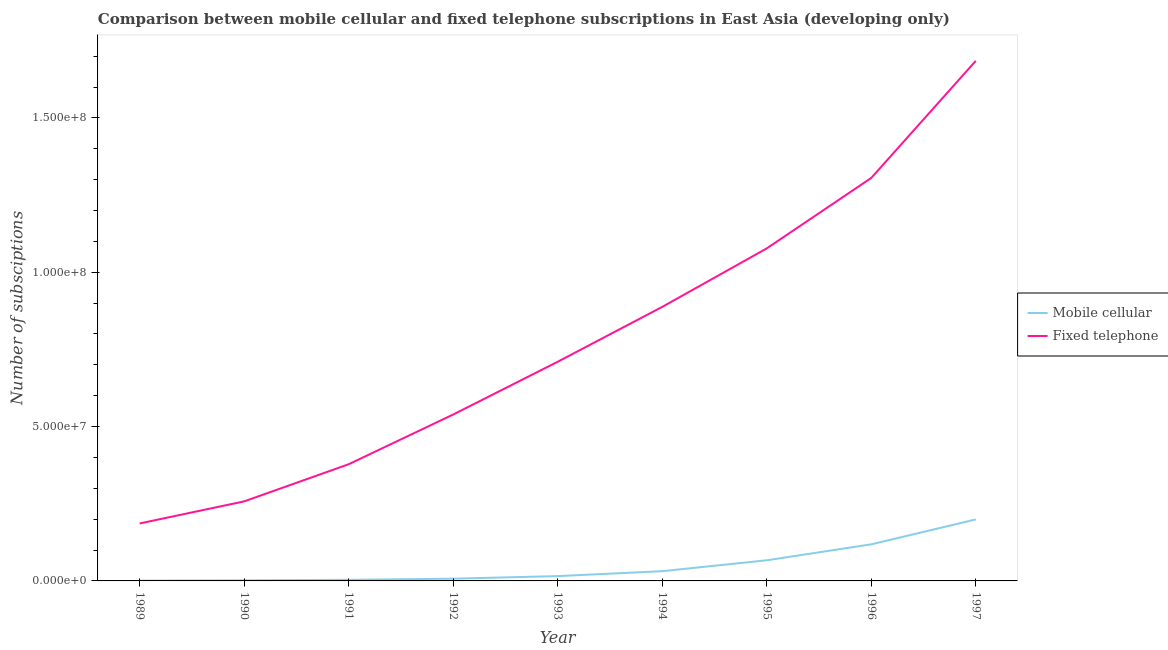How many different coloured lines are there?
Give a very brief answer. 2. Does the line corresponding to number of fixed telephone subscriptions intersect with the line corresponding to number of mobile cellular subscriptions?
Offer a terse response. No. What is the number of fixed telephone subscriptions in 1992?
Provide a succinct answer. 5.39e+07. Across all years, what is the maximum number of mobile cellular subscriptions?
Provide a succinct answer. 1.99e+07. Across all years, what is the minimum number of mobile cellular subscriptions?
Keep it short and to the point. 1.02e+05. In which year was the number of mobile cellular subscriptions maximum?
Provide a short and direct response. 1997. In which year was the number of mobile cellular subscriptions minimum?
Offer a terse response. 1989. What is the total number of fixed telephone subscriptions in the graph?
Provide a short and direct response. 7.03e+08. What is the difference between the number of fixed telephone subscriptions in 1989 and that in 1993?
Provide a succinct answer. -5.24e+07. What is the difference between the number of mobile cellular subscriptions in 1992 and the number of fixed telephone subscriptions in 1997?
Ensure brevity in your answer.  -1.68e+08. What is the average number of mobile cellular subscriptions per year?
Your response must be concise. 4.95e+06. In the year 1990, what is the difference between the number of mobile cellular subscriptions and number of fixed telephone subscriptions?
Keep it short and to the point. -2.56e+07. In how many years, is the number of mobile cellular subscriptions greater than 50000000?
Keep it short and to the point. 0. What is the ratio of the number of fixed telephone subscriptions in 1990 to that in 1994?
Give a very brief answer. 0.29. Is the number of mobile cellular subscriptions in 1992 less than that in 1996?
Make the answer very short. Yes. What is the difference between the highest and the second highest number of mobile cellular subscriptions?
Give a very brief answer. 8.07e+06. What is the difference between the highest and the lowest number of fixed telephone subscriptions?
Provide a succinct answer. 1.50e+08. Is the number of mobile cellular subscriptions strictly greater than the number of fixed telephone subscriptions over the years?
Give a very brief answer. No. Is the number of mobile cellular subscriptions strictly less than the number of fixed telephone subscriptions over the years?
Offer a terse response. Yes. Are the values on the major ticks of Y-axis written in scientific E-notation?
Keep it short and to the point. Yes. Does the graph contain any zero values?
Provide a short and direct response. No. Does the graph contain grids?
Provide a succinct answer. No. Where does the legend appear in the graph?
Offer a terse response. Center right. How are the legend labels stacked?
Offer a very short reply. Vertical. What is the title of the graph?
Offer a terse response. Comparison between mobile cellular and fixed telephone subscriptions in East Asia (developing only). Does "Measles" appear as one of the legend labels in the graph?
Make the answer very short. No. What is the label or title of the Y-axis?
Provide a succinct answer. Number of subsciptions. What is the Number of subsciptions of Mobile cellular in 1989?
Make the answer very short. 1.02e+05. What is the Number of subsciptions in Fixed telephone in 1989?
Offer a very short reply. 1.86e+07. What is the Number of subsciptions in Mobile cellular in 1990?
Offer a terse response. 1.86e+05. What is the Number of subsciptions in Fixed telephone in 1990?
Make the answer very short. 2.58e+07. What is the Number of subsciptions in Mobile cellular in 1991?
Make the answer very short. 3.60e+05. What is the Number of subsciptions in Fixed telephone in 1991?
Offer a very short reply. 3.78e+07. What is the Number of subsciptions of Mobile cellular in 1992?
Make the answer very short. 7.21e+05. What is the Number of subsciptions of Fixed telephone in 1992?
Provide a succinct answer. 5.39e+07. What is the Number of subsciptions of Mobile cellular in 1993?
Offer a very short reply. 1.56e+06. What is the Number of subsciptions in Fixed telephone in 1993?
Your answer should be compact. 7.10e+07. What is the Number of subsciptions in Mobile cellular in 1994?
Provide a succinct answer. 3.16e+06. What is the Number of subsciptions in Fixed telephone in 1994?
Make the answer very short. 8.88e+07. What is the Number of subsciptions of Mobile cellular in 1995?
Provide a short and direct response. 6.68e+06. What is the Number of subsciptions in Fixed telephone in 1995?
Your answer should be compact. 1.08e+08. What is the Number of subsciptions in Mobile cellular in 1996?
Provide a short and direct response. 1.19e+07. What is the Number of subsciptions in Fixed telephone in 1996?
Your answer should be compact. 1.31e+08. What is the Number of subsciptions of Mobile cellular in 1997?
Make the answer very short. 1.99e+07. What is the Number of subsciptions of Fixed telephone in 1997?
Your response must be concise. 1.68e+08. Across all years, what is the maximum Number of subsciptions of Mobile cellular?
Offer a terse response. 1.99e+07. Across all years, what is the maximum Number of subsciptions of Fixed telephone?
Ensure brevity in your answer.  1.68e+08. Across all years, what is the minimum Number of subsciptions of Mobile cellular?
Offer a very short reply. 1.02e+05. Across all years, what is the minimum Number of subsciptions in Fixed telephone?
Offer a terse response. 1.86e+07. What is the total Number of subsciptions in Mobile cellular in the graph?
Your answer should be compact. 4.45e+07. What is the total Number of subsciptions of Fixed telephone in the graph?
Ensure brevity in your answer.  7.03e+08. What is the difference between the Number of subsciptions in Mobile cellular in 1989 and that in 1990?
Offer a terse response. -8.42e+04. What is the difference between the Number of subsciptions in Fixed telephone in 1989 and that in 1990?
Offer a very short reply. -7.16e+06. What is the difference between the Number of subsciptions of Mobile cellular in 1989 and that in 1991?
Your answer should be very brief. -2.58e+05. What is the difference between the Number of subsciptions in Fixed telephone in 1989 and that in 1991?
Your response must be concise. -1.92e+07. What is the difference between the Number of subsciptions of Mobile cellular in 1989 and that in 1992?
Provide a short and direct response. -6.19e+05. What is the difference between the Number of subsciptions of Fixed telephone in 1989 and that in 1992?
Ensure brevity in your answer.  -3.53e+07. What is the difference between the Number of subsciptions in Mobile cellular in 1989 and that in 1993?
Your answer should be compact. -1.46e+06. What is the difference between the Number of subsciptions of Fixed telephone in 1989 and that in 1993?
Offer a very short reply. -5.24e+07. What is the difference between the Number of subsciptions of Mobile cellular in 1989 and that in 1994?
Offer a very short reply. -3.05e+06. What is the difference between the Number of subsciptions of Fixed telephone in 1989 and that in 1994?
Keep it short and to the point. -7.02e+07. What is the difference between the Number of subsciptions in Mobile cellular in 1989 and that in 1995?
Provide a succinct answer. -6.58e+06. What is the difference between the Number of subsciptions in Fixed telephone in 1989 and that in 1995?
Ensure brevity in your answer.  -8.91e+07. What is the difference between the Number of subsciptions in Mobile cellular in 1989 and that in 1996?
Ensure brevity in your answer.  -1.17e+07. What is the difference between the Number of subsciptions in Fixed telephone in 1989 and that in 1996?
Your response must be concise. -1.12e+08. What is the difference between the Number of subsciptions in Mobile cellular in 1989 and that in 1997?
Your answer should be compact. -1.98e+07. What is the difference between the Number of subsciptions of Fixed telephone in 1989 and that in 1997?
Ensure brevity in your answer.  -1.50e+08. What is the difference between the Number of subsciptions in Mobile cellular in 1990 and that in 1991?
Provide a succinct answer. -1.74e+05. What is the difference between the Number of subsciptions in Fixed telephone in 1990 and that in 1991?
Make the answer very short. -1.20e+07. What is the difference between the Number of subsciptions of Mobile cellular in 1990 and that in 1992?
Provide a succinct answer. -5.35e+05. What is the difference between the Number of subsciptions in Fixed telephone in 1990 and that in 1992?
Offer a very short reply. -2.81e+07. What is the difference between the Number of subsciptions in Mobile cellular in 1990 and that in 1993?
Make the answer very short. -1.37e+06. What is the difference between the Number of subsciptions of Fixed telephone in 1990 and that in 1993?
Ensure brevity in your answer.  -4.52e+07. What is the difference between the Number of subsciptions of Mobile cellular in 1990 and that in 1994?
Provide a short and direct response. -2.97e+06. What is the difference between the Number of subsciptions of Fixed telephone in 1990 and that in 1994?
Offer a terse response. -6.30e+07. What is the difference between the Number of subsciptions in Mobile cellular in 1990 and that in 1995?
Provide a short and direct response. -6.50e+06. What is the difference between the Number of subsciptions in Fixed telephone in 1990 and that in 1995?
Ensure brevity in your answer.  -8.20e+07. What is the difference between the Number of subsciptions in Mobile cellular in 1990 and that in 1996?
Your answer should be very brief. -1.17e+07. What is the difference between the Number of subsciptions in Fixed telephone in 1990 and that in 1996?
Ensure brevity in your answer.  -1.05e+08. What is the difference between the Number of subsciptions in Mobile cellular in 1990 and that in 1997?
Give a very brief answer. -1.97e+07. What is the difference between the Number of subsciptions of Fixed telephone in 1990 and that in 1997?
Your answer should be compact. -1.43e+08. What is the difference between the Number of subsciptions of Mobile cellular in 1991 and that in 1992?
Your answer should be very brief. -3.61e+05. What is the difference between the Number of subsciptions of Fixed telephone in 1991 and that in 1992?
Your response must be concise. -1.61e+07. What is the difference between the Number of subsciptions in Mobile cellular in 1991 and that in 1993?
Make the answer very short. -1.20e+06. What is the difference between the Number of subsciptions of Fixed telephone in 1991 and that in 1993?
Ensure brevity in your answer.  -3.32e+07. What is the difference between the Number of subsciptions of Mobile cellular in 1991 and that in 1994?
Provide a short and direct response. -2.79e+06. What is the difference between the Number of subsciptions of Fixed telephone in 1991 and that in 1994?
Provide a succinct answer. -5.10e+07. What is the difference between the Number of subsciptions of Mobile cellular in 1991 and that in 1995?
Provide a short and direct response. -6.32e+06. What is the difference between the Number of subsciptions in Fixed telephone in 1991 and that in 1995?
Your answer should be very brief. -6.99e+07. What is the difference between the Number of subsciptions of Mobile cellular in 1991 and that in 1996?
Offer a very short reply. -1.15e+07. What is the difference between the Number of subsciptions in Fixed telephone in 1991 and that in 1996?
Your response must be concise. -9.28e+07. What is the difference between the Number of subsciptions of Mobile cellular in 1991 and that in 1997?
Offer a very short reply. -1.96e+07. What is the difference between the Number of subsciptions in Fixed telephone in 1991 and that in 1997?
Your answer should be compact. -1.31e+08. What is the difference between the Number of subsciptions of Mobile cellular in 1992 and that in 1993?
Your response must be concise. -8.37e+05. What is the difference between the Number of subsciptions in Fixed telephone in 1992 and that in 1993?
Your answer should be very brief. -1.71e+07. What is the difference between the Number of subsciptions of Mobile cellular in 1992 and that in 1994?
Provide a succinct answer. -2.43e+06. What is the difference between the Number of subsciptions in Fixed telephone in 1992 and that in 1994?
Make the answer very short. -3.49e+07. What is the difference between the Number of subsciptions of Mobile cellular in 1992 and that in 1995?
Make the answer very short. -5.96e+06. What is the difference between the Number of subsciptions in Fixed telephone in 1992 and that in 1995?
Your answer should be compact. -5.38e+07. What is the difference between the Number of subsciptions in Mobile cellular in 1992 and that in 1996?
Give a very brief answer. -1.11e+07. What is the difference between the Number of subsciptions in Fixed telephone in 1992 and that in 1996?
Offer a very short reply. -7.66e+07. What is the difference between the Number of subsciptions in Mobile cellular in 1992 and that in 1997?
Make the answer very short. -1.92e+07. What is the difference between the Number of subsciptions of Fixed telephone in 1992 and that in 1997?
Provide a succinct answer. -1.15e+08. What is the difference between the Number of subsciptions of Mobile cellular in 1993 and that in 1994?
Offer a terse response. -1.60e+06. What is the difference between the Number of subsciptions in Fixed telephone in 1993 and that in 1994?
Your answer should be compact. -1.78e+07. What is the difference between the Number of subsciptions in Mobile cellular in 1993 and that in 1995?
Provide a succinct answer. -5.12e+06. What is the difference between the Number of subsciptions of Fixed telephone in 1993 and that in 1995?
Provide a short and direct response. -3.67e+07. What is the difference between the Number of subsciptions of Mobile cellular in 1993 and that in 1996?
Your answer should be compact. -1.03e+07. What is the difference between the Number of subsciptions of Fixed telephone in 1993 and that in 1996?
Offer a very short reply. -5.96e+07. What is the difference between the Number of subsciptions of Mobile cellular in 1993 and that in 1997?
Your answer should be compact. -1.84e+07. What is the difference between the Number of subsciptions of Fixed telephone in 1993 and that in 1997?
Provide a short and direct response. -9.75e+07. What is the difference between the Number of subsciptions of Mobile cellular in 1994 and that in 1995?
Provide a succinct answer. -3.53e+06. What is the difference between the Number of subsciptions of Fixed telephone in 1994 and that in 1995?
Your answer should be very brief. -1.89e+07. What is the difference between the Number of subsciptions in Mobile cellular in 1994 and that in 1996?
Your answer should be very brief. -8.70e+06. What is the difference between the Number of subsciptions of Fixed telephone in 1994 and that in 1996?
Give a very brief answer. -4.18e+07. What is the difference between the Number of subsciptions of Mobile cellular in 1994 and that in 1997?
Give a very brief answer. -1.68e+07. What is the difference between the Number of subsciptions of Fixed telephone in 1994 and that in 1997?
Provide a short and direct response. -7.97e+07. What is the difference between the Number of subsciptions of Mobile cellular in 1995 and that in 1996?
Offer a very short reply. -5.17e+06. What is the difference between the Number of subsciptions of Fixed telephone in 1995 and that in 1996?
Give a very brief answer. -2.28e+07. What is the difference between the Number of subsciptions in Mobile cellular in 1995 and that in 1997?
Keep it short and to the point. -1.32e+07. What is the difference between the Number of subsciptions of Fixed telephone in 1995 and that in 1997?
Ensure brevity in your answer.  -6.08e+07. What is the difference between the Number of subsciptions in Mobile cellular in 1996 and that in 1997?
Provide a succinct answer. -8.07e+06. What is the difference between the Number of subsciptions in Fixed telephone in 1996 and that in 1997?
Make the answer very short. -3.79e+07. What is the difference between the Number of subsciptions of Mobile cellular in 1989 and the Number of subsciptions of Fixed telephone in 1990?
Your answer should be compact. -2.57e+07. What is the difference between the Number of subsciptions of Mobile cellular in 1989 and the Number of subsciptions of Fixed telephone in 1991?
Offer a very short reply. -3.77e+07. What is the difference between the Number of subsciptions in Mobile cellular in 1989 and the Number of subsciptions in Fixed telephone in 1992?
Provide a short and direct response. -5.38e+07. What is the difference between the Number of subsciptions in Mobile cellular in 1989 and the Number of subsciptions in Fixed telephone in 1993?
Offer a terse response. -7.09e+07. What is the difference between the Number of subsciptions in Mobile cellular in 1989 and the Number of subsciptions in Fixed telephone in 1994?
Your response must be concise. -8.87e+07. What is the difference between the Number of subsciptions of Mobile cellular in 1989 and the Number of subsciptions of Fixed telephone in 1995?
Give a very brief answer. -1.08e+08. What is the difference between the Number of subsciptions of Mobile cellular in 1989 and the Number of subsciptions of Fixed telephone in 1996?
Keep it short and to the point. -1.30e+08. What is the difference between the Number of subsciptions in Mobile cellular in 1989 and the Number of subsciptions in Fixed telephone in 1997?
Ensure brevity in your answer.  -1.68e+08. What is the difference between the Number of subsciptions in Mobile cellular in 1990 and the Number of subsciptions in Fixed telephone in 1991?
Your answer should be compact. -3.76e+07. What is the difference between the Number of subsciptions of Mobile cellular in 1990 and the Number of subsciptions of Fixed telephone in 1992?
Offer a very short reply. -5.37e+07. What is the difference between the Number of subsciptions of Mobile cellular in 1990 and the Number of subsciptions of Fixed telephone in 1993?
Keep it short and to the point. -7.08e+07. What is the difference between the Number of subsciptions in Mobile cellular in 1990 and the Number of subsciptions in Fixed telephone in 1994?
Offer a terse response. -8.86e+07. What is the difference between the Number of subsciptions in Mobile cellular in 1990 and the Number of subsciptions in Fixed telephone in 1995?
Offer a very short reply. -1.08e+08. What is the difference between the Number of subsciptions of Mobile cellular in 1990 and the Number of subsciptions of Fixed telephone in 1996?
Ensure brevity in your answer.  -1.30e+08. What is the difference between the Number of subsciptions of Mobile cellular in 1990 and the Number of subsciptions of Fixed telephone in 1997?
Ensure brevity in your answer.  -1.68e+08. What is the difference between the Number of subsciptions in Mobile cellular in 1991 and the Number of subsciptions in Fixed telephone in 1992?
Keep it short and to the point. -5.36e+07. What is the difference between the Number of subsciptions of Mobile cellular in 1991 and the Number of subsciptions of Fixed telephone in 1993?
Offer a terse response. -7.06e+07. What is the difference between the Number of subsciptions in Mobile cellular in 1991 and the Number of subsciptions in Fixed telephone in 1994?
Make the answer very short. -8.84e+07. What is the difference between the Number of subsciptions in Mobile cellular in 1991 and the Number of subsciptions in Fixed telephone in 1995?
Keep it short and to the point. -1.07e+08. What is the difference between the Number of subsciptions of Mobile cellular in 1991 and the Number of subsciptions of Fixed telephone in 1996?
Ensure brevity in your answer.  -1.30e+08. What is the difference between the Number of subsciptions in Mobile cellular in 1991 and the Number of subsciptions in Fixed telephone in 1997?
Offer a terse response. -1.68e+08. What is the difference between the Number of subsciptions in Mobile cellular in 1992 and the Number of subsciptions in Fixed telephone in 1993?
Your answer should be compact. -7.03e+07. What is the difference between the Number of subsciptions of Mobile cellular in 1992 and the Number of subsciptions of Fixed telephone in 1994?
Ensure brevity in your answer.  -8.81e+07. What is the difference between the Number of subsciptions in Mobile cellular in 1992 and the Number of subsciptions in Fixed telephone in 1995?
Offer a terse response. -1.07e+08. What is the difference between the Number of subsciptions of Mobile cellular in 1992 and the Number of subsciptions of Fixed telephone in 1996?
Provide a succinct answer. -1.30e+08. What is the difference between the Number of subsciptions in Mobile cellular in 1992 and the Number of subsciptions in Fixed telephone in 1997?
Your answer should be very brief. -1.68e+08. What is the difference between the Number of subsciptions in Mobile cellular in 1993 and the Number of subsciptions in Fixed telephone in 1994?
Make the answer very short. -8.72e+07. What is the difference between the Number of subsciptions in Mobile cellular in 1993 and the Number of subsciptions in Fixed telephone in 1995?
Offer a very short reply. -1.06e+08. What is the difference between the Number of subsciptions of Mobile cellular in 1993 and the Number of subsciptions of Fixed telephone in 1996?
Give a very brief answer. -1.29e+08. What is the difference between the Number of subsciptions of Mobile cellular in 1993 and the Number of subsciptions of Fixed telephone in 1997?
Your answer should be compact. -1.67e+08. What is the difference between the Number of subsciptions in Mobile cellular in 1994 and the Number of subsciptions in Fixed telephone in 1995?
Ensure brevity in your answer.  -1.05e+08. What is the difference between the Number of subsciptions of Mobile cellular in 1994 and the Number of subsciptions of Fixed telephone in 1996?
Give a very brief answer. -1.27e+08. What is the difference between the Number of subsciptions of Mobile cellular in 1994 and the Number of subsciptions of Fixed telephone in 1997?
Ensure brevity in your answer.  -1.65e+08. What is the difference between the Number of subsciptions of Mobile cellular in 1995 and the Number of subsciptions of Fixed telephone in 1996?
Make the answer very short. -1.24e+08. What is the difference between the Number of subsciptions in Mobile cellular in 1995 and the Number of subsciptions in Fixed telephone in 1997?
Your answer should be very brief. -1.62e+08. What is the difference between the Number of subsciptions in Mobile cellular in 1996 and the Number of subsciptions in Fixed telephone in 1997?
Offer a very short reply. -1.57e+08. What is the average Number of subsciptions of Mobile cellular per year?
Keep it short and to the point. 4.95e+06. What is the average Number of subsciptions of Fixed telephone per year?
Provide a short and direct response. 7.81e+07. In the year 1989, what is the difference between the Number of subsciptions of Mobile cellular and Number of subsciptions of Fixed telephone?
Your response must be concise. -1.85e+07. In the year 1990, what is the difference between the Number of subsciptions in Mobile cellular and Number of subsciptions in Fixed telephone?
Ensure brevity in your answer.  -2.56e+07. In the year 1991, what is the difference between the Number of subsciptions in Mobile cellular and Number of subsciptions in Fixed telephone?
Offer a terse response. -3.74e+07. In the year 1992, what is the difference between the Number of subsciptions in Mobile cellular and Number of subsciptions in Fixed telephone?
Provide a short and direct response. -5.32e+07. In the year 1993, what is the difference between the Number of subsciptions of Mobile cellular and Number of subsciptions of Fixed telephone?
Offer a terse response. -6.94e+07. In the year 1994, what is the difference between the Number of subsciptions in Mobile cellular and Number of subsciptions in Fixed telephone?
Provide a succinct answer. -8.56e+07. In the year 1995, what is the difference between the Number of subsciptions of Mobile cellular and Number of subsciptions of Fixed telephone?
Provide a succinct answer. -1.01e+08. In the year 1996, what is the difference between the Number of subsciptions of Mobile cellular and Number of subsciptions of Fixed telephone?
Make the answer very short. -1.19e+08. In the year 1997, what is the difference between the Number of subsciptions of Mobile cellular and Number of subsciptions of Fixed telephone?
Keep it short and to the point. -1.49e+08. What is the ratio of the Number of subsciptions in Mobile cellular in 1989 to that in 1990?
Your answer should be compact. 0.55. What is the ratio of the Number of subsciptions in Fixed telephone in 1989 to that in 1990?
Provide a succinct answer. 0.72. What is the ratio of the Number of subsciptions in Mobile cellular in 1989 to that in 1991?
Make the answer very short. 0.28. What is the ratio of the Number of subsciptions of Fixed telephone in 1989 to that in 1991?
Your response must be concise. 0.49. What is the ratio of the Number of subsciptions of Mobile cellular in 1989 to that in 1992?
Ensure brevity in your answer.  0.14. What is the ratio of the Number of subsciptions of Fixed telephone in 1989 to that in 1992?
Ensure brevity in your answer.  0.35. What is the ratio of the Number of subsciptions of Mobile cellular in 1989 to that in 1993?
Offer a terse response. 0.07. What is the ratio of the Number of subsciptions of Fixed telephone in 1989 to that in 1993?
Ensure brevity in your answer.  0.26. What is the ratio of the Number of subsciptions in Mobile cellular in 1989 to that in 1994?
Make the answer very short. 0.03. What is the ratio of the Number of subsciptions in Fixed telephone in 1989 to that in 1994?
Offer a very short reply. 0.21. What is the ratio of the Number of subsciptions of Mobile cellular in 1989 to that in 1995?
Provide a short and direct response. 0.02. What is the ratio of the Number of subsciptions in Fixed telephone in 1989 to that in 1995?
Give a very brief answer. 0.17. What is the ratio of the Number of subsciptions in Mobile cellular in 1989 to that in 1996?
Provide a succinct answer. 0.01. What is the ratio of the Number of subsciptions in Fixed telephone in 1989 to that in 1996?
Offer a terse response. 0.14. What is the ratio of the Number of subsciptions of Mobile cellular in 1989 to that in 1997?
Provide a succinct answer. 0.01. What is the ratio of the Number of subsciptions of Fixed telephone in 1989 to that in 1997?
Make the answer very short. 0.11. What is the ratio of the Number of subsciptions of Mobile cellular in 1990 to that in 1991?
Your response must be concise. 0.52. What is the ratio of the Number of subsciptions of Fixed telephone in 1990 to that in 1991?
Your answer should be very brief. 0.68. What is the ratio of the Number of subsciptions in Mobile cellular in 1990 to that in 1992?
Provide a succinct answer. 0.26. What is the ratio of the Number of subsciptions of Fixed telephone in 1990 to that in 1992?
Your response must be concise. 0.48. What is the ratio of the Number of subsciptions in Mobile cellular in 1990 to that in 1993?
Offer a terse response. 0.12. What is the ratio of the Number of subsciptions in Fixed telephone in 1990 to that in 1993?
Offer a very short reply. 0.36. What is the ratio of the Number of subsciptions in Mobile cellular in 1990 to that in 1994?
Offer a terse response. 0.06. What is the ratio of the Number of subsciptions in Fixed telephone in 1990 to that in 1994?
Give a very brief answer. 0.29. What is the ratio of the Number of subsciptions of Mobile cellular in 1990 to that in 1995?
Keep it short and to the point. 0.03. What is the ratio of the Number of subsciptions in Fixed telephone in 1990 to that in 1995?
Give a very brief answer. 0.24. What is the ratio of the Number of subsciptions of Mobile cellular in 1990 to that in 1996?
Offer a very short reply. 0.02. What is the ratio of the Number of subsciptions in Fixed telephone in 1990 to that in 1996?
Give a very brief answer. 0.2. What is the ratio of the Number of subsciptions in Mobile cellular in 1990 to that in 1997?
Your answer should be compact. 0.01. What is the ratio of the Number of subsciptions of Fixed telephone in 1990 to that in 1997?
Keep it short and to the point. 0.15. What is the ratio of the Number of subsciptions of Mobile cellular in 1991 to that in 1992?
Offer a terse response. 0.5. What is the ratio of the Number of subsciptions in Fixed telephone in 1991 to that in 1992?
Your response must be concise. 0.7. What is the ratio of the Number of subsciptions of Mobile cellular in 1991 to that in 1993?
Offer a terse response. 0.23. What is the ratio of the Number of subsciptions of Fixed telephone in 1991 to that in 1993?
Make the answer very short. 0.53. What is the ratio of the Number of subsciptions of Mobile cellular in 1991 to that in 1994?
Make the answer very short. 0.11. What is the ratio of the Number of subsciptions in Fixed telephone in 1991 to that in 1994?
Provide a short and direct response. 0.43. What is the ratio of the Number of subsciptions of Mobile cellular in 1991 to that in 1995?
Offer a very short reply. 0.05. What is the ratio of the Number of subsciptions in Fixed telephone in 1991 to that in 1995?
Provide a succinct answer. 0.35. What is the ratio of the Number of subsciptions of Mobile cellular in 1991 to that in 1996?
Provide a short and direct response. 0.03. What is the ratio of the Number of subsciptions of Fixed telephone in 1991 to that in 1996?
Provide a short and direct response. 0.29. What is the ratio of the Number of subsciptions of Mobile cellular in 1991 to that in 1997?
Your response must be concise. 0.02. What is the ratio of the Number of subsciptions in Fixed telephone in 1991 to that in 1997?
Your answer should be very brief. 0.22. What is the ratio of the Number of subsciptions in Mobile cellular in 1992 to that in 1993?
Provide a succinct answer. 0.46. What is the ratio of the Number of subsciptions of Fixed telephone in 1992 to that in 1993?
Provide a succinct answer. 0.76. What is the ratio of the Number of subsciptions in Mobile cellular in 1992 to that in 1994?
Keep it short and to the point. 0.23. What is the ratio of the Number of subsciptions of Fixed telephone in 1992 to that in 1994?
Give a very brief answer. 0.61. What is the ratio of the Number of subsciptions of Mobile cellular in 1992 to that in 1995?
Your answer should be compact. 0.11. What is the ratio of the Number of subsciptions in Fixed telephone in 1992 to that in 1995?
Give a very brief answer. 0.5. What is the ratio of the Number of subsciptions of Mobile cellular in 1992 to that in 1996?
Your answer should be very brief. 0.06. What is the ratio of the Number of subsciptions of Fixed telephone in 1992 to that in 1996?
Offer a terse response. 0.41. What is the ratio of the Number of subsciptions of Mobile cellular in 1992 to that in 1997?
Your answer should be very brief. 0.04. What is the ratio of the Number of subsciptions of Fixed telephone in 1992 to that in 1997?
Provide a short and direct response. 0.32. What is the ratio of the Number of subsciptions in Mobile cellular in 1993 to that in 1994?
Your response must be concise. 0.49. What is the ratio of the Number of subsciptions in Fixed telephone in 1993 to that in 1994?
Your answer should be very brief. 0.8. What is the ratio of the Number of subsciptions in Mobile cellular in 1993 to that in 1995?
Give a very brief answer. 0.23. What is the ratio of the Number of subsciptions in Fixed telephone in 1993 to that in 1995?
Keep it short and to the point. 0.66. What is the ratio of the Number of subsciptions in Mobile cellular in 1993 to that in 1996?
Give a very brief answer. 0.13. What is the ratio of the Number of subsciptions in Fixed telephone in 1993 to that in 1996?
Your answer should be compact. 0.54. What is the ratio of the Number of subsciptions of Mobile cellular in 1993 to that in 1997?
Make the answer very short. 0.08. What is the ratio of the Number of subsciptions in Fixed telephone in 1993 to that in 1997?
Ensure brevity in your answer.  0.42. What is the ratio of the Number of subsciptions in Mobile cellular in 1994 to that in 1995?
Give a very brief answer. 0.47. What is the ratio of the Number of subsciptions of Fixed telephone in 1994 to that in 1995?
Your answer should be compact. 0.82. What is the ratio of the Number of subsciptions in Mobile cellular in 1994 to that in 1996?
Provide a short and direct response. 0.27. What is the ratio of the Number of subsciptions of Fixed telephone in 1994 to that in 1996?
Offer a terse response. 0.68. What is the ratio of the Number of subsciptions in Mobile cellular in 1994 to that in 1997?
Your answer should be compact. 0.16. What is the ratio of the Number of subsciptions of Fixed telephone in 1994 to that in 1997?
Your answer should be very brief. 0.53. What is the ratio of the Number of subsciptions of Mobile cellular in 1995 to that in 1996?
Your answer should be compact. 0.56. What is the ratio of the Number of subsciptions of Fixed telephone in 1995 to that in 1996?
Offer a terse response. 0.83. What is the ratio of the Number of subsciptions in Mobile cellular in 1995 to that in 1997?
Ensure brevity in your answer.  0.34. What is the ratio of the Number of subsciptions of Fixed telephone in 1995 to that in 1997?
Ensure brevity in your answer.  0.64. What is the ratio of the Number of subsciptions in Mobile cellular in 1996 to that in 1997?
Your answer should be very brief. 0.59. What is the ratio of the Number of subsciptions in Fixed telephone in 1996 to that in 1997?
Ensure brevity in your answer.  0.77. What is the difference between the highest and the second highest Number of subsciptions in Mobile cellular?
Your answer should be compact. 8.07e+06. What is the difference between the highest and the second highest Number of subsciptions in Fixed telephone?
Keep it short and to the point. 3.79e+07. What is the difference between the highest and the lowest Number of subsciptions in Mobile cellular?
Ensure brevity in your answer.  1.98e+07. What is the difference between the highest and the lowest Number of subsciptions in Fixed telephone?
Offer a very short reply. 1.50e+08. 